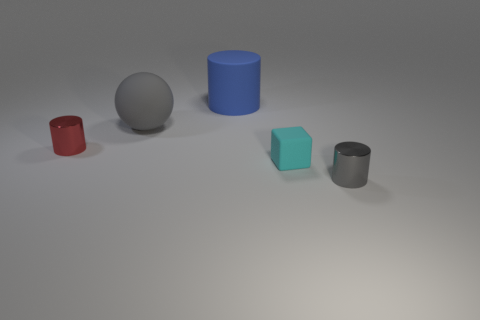How many large things are rubber cubes or blue rubber things?
Offer a very short reply. 1. Is the color of the small cylinder that is to the right of the large gray rubber object the same as the large matte object that is in front of the big blue cylinder?
Offer a terse response. Yes. What number of other objects are there of the same color as the sphere?
Provide a succinct answer. 1. There is a small shiny object that is on the right side of the tiny red object; what shape is it?
Your answer should be compact. Cylinder. Are there fewer blue rubber cylinders than gray things?
Ensure brevity in your answer.  Yes. Do the blue thing that is behind the gray metal thing and the small cyan cube have the same material?
Provide a short and direct response. Yes. There is a gray cylinder; are there any small metal objects left of it?
Give a very brief answer. Yes. The small metallic object that is on the left side of the big object in front of the object behind the big gray rubber ball is what color?
Your answer should be very brief. Red. The gray object that is the same size as the red metallic cylinder is what shape?
Provide a short and direct response. Cylinder. Is the number of tiny gray metallic things greater than the number of small yellow cylinders?
Keep it short and to the point. Yes. 